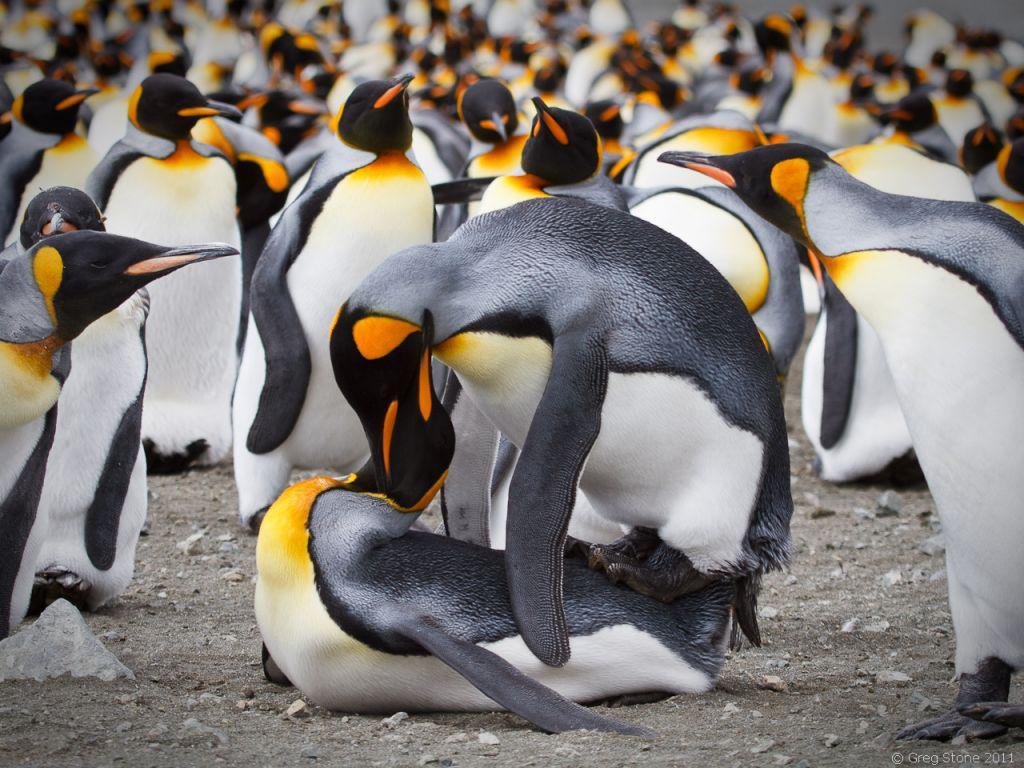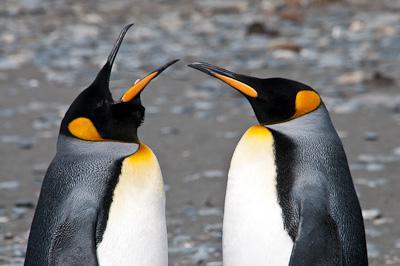The first image is the image on the left, the second image is the image on the right. Evaluate the accuracy of this statement regarding the images: "There are exactly animals in the image on the right.". Is it true? Answer yes or no. Yes. 